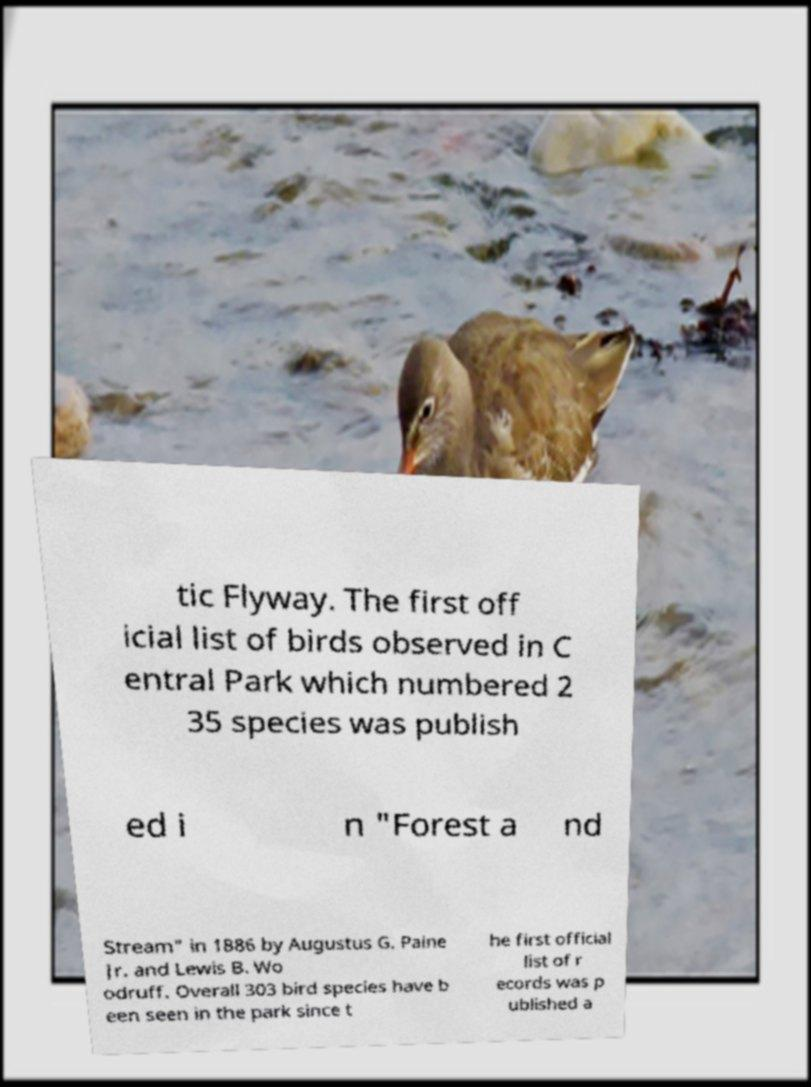Could you extract and type out the text from this image? tic Flyway. The first off icial list of birds observed in C entral Park which numbered 2 35 species was publish ed i n "Forest a nd Stream" in 1886 by Augustus G. Paine Jr. and Lewis B. Wo odruff. Overall 303 bird species have b een seen in the park since t he first official list of r ecords was p ublished a 